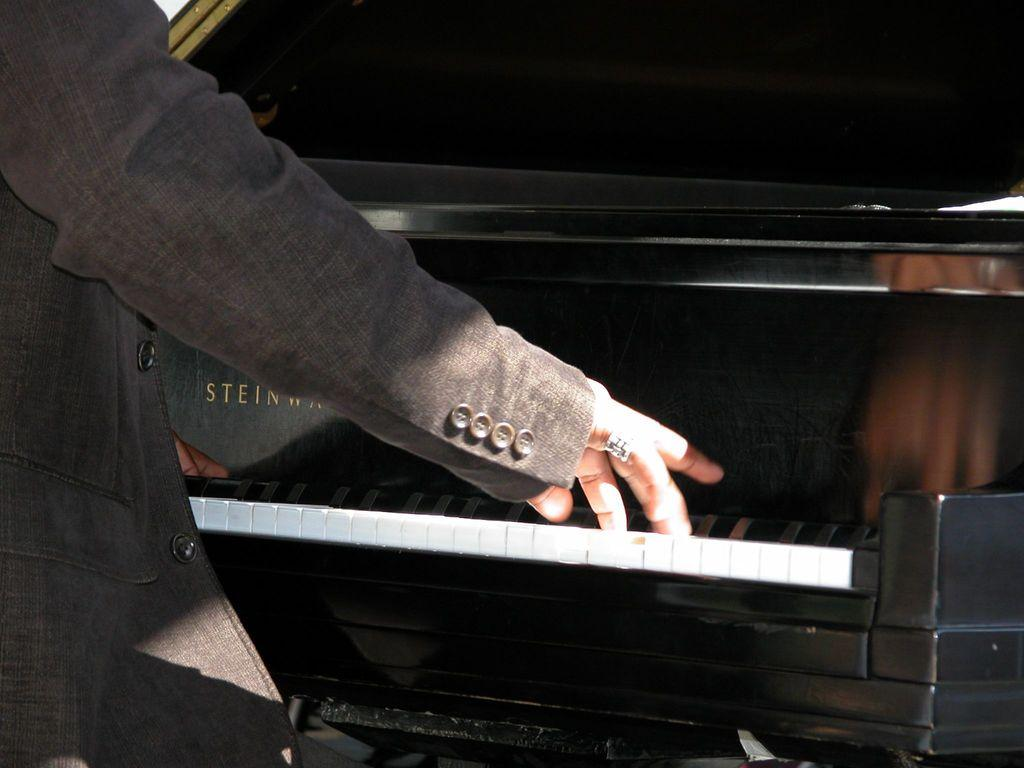What is the main subject of the image? The main subject of the image is a man. What is the man doing in the image? The man is playing a piano keyboard in the image. Where is the library located in the image? There is no library present in the image; it features a man playing a piano keyboard. What type of match is the man participating in the image? There is no match or competition present in the image; it features a man playing a piano keyboard. 